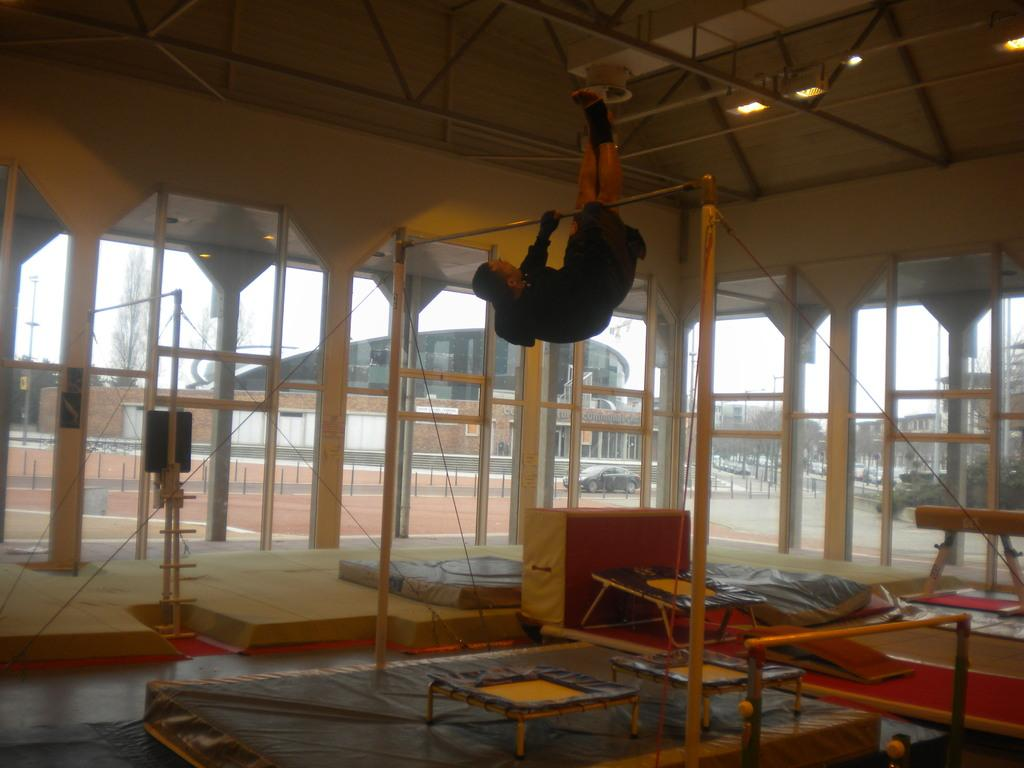What is happening in the image? There is a person in the image doing pull-ups. Can you describe the person's activity in more detail? The person is lifting their body up and down using a horizontal bar. How many rabbits are visible in the image? There are no rabbits present in the image. What type of advertisement is being displayed in the background of the image? There is no advertisement visible in the image; it only features a person doing pull-ups. 